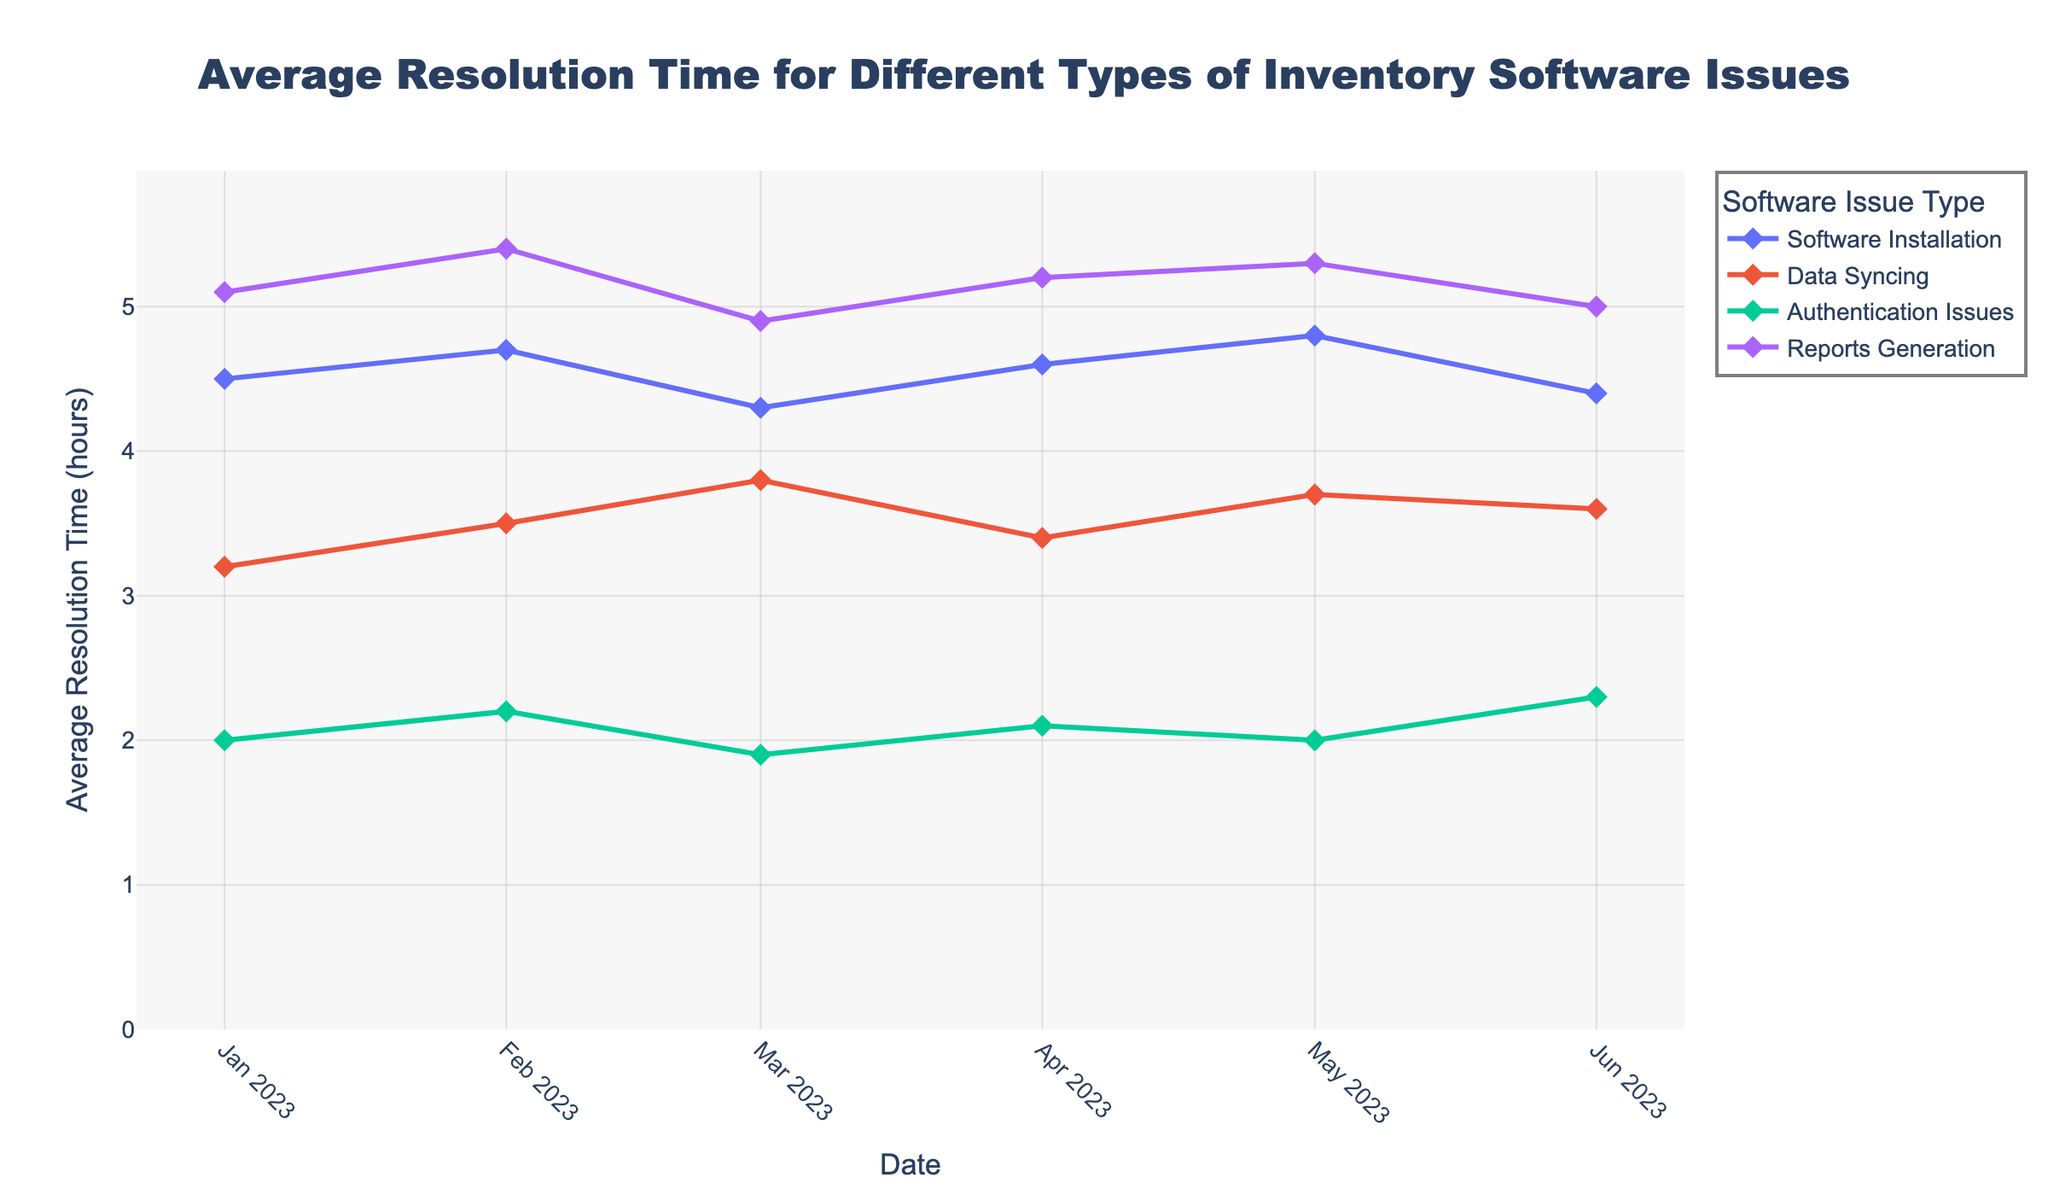What is the title of the plot? The title of the plot is displayed at the top center of the figure. It generally summarizes the main point of the plot.
Answer: Average Resolution Time for Different Types of Inventory Software Issues What is the average resolution time for 'Reports Generation' issues in January 2023? Locate the data point for 'Reports Generation' on January 2023 on the time series plot. The y-axis value at this point indicates the average resolution time.
Answer: 5.1 hours How does the average resolution time for 'Data Syncing' issues in February 2023 compare to that in March 2023? Compare the y-axis values for 'Data Syncing' on the dates February 2023 and March 2023. Subtract the March value from the February value.
Answer: February: 3.5 hours, March: 3.8 hours. Increase by 0.3 hours Which issue type had the lowest average resolution time in June 2023? Find the data points for each issue type in June 2023 and compare their y-axis values. The lowest value indicates the issue type with the shortest resolution time.
Answer: Authentication Issues What is the date range covered in this plot? The x-axis shows the dates of the data points. Determine the first and last dates displayed on the x-axis.
Answer: January 2023 to June 2023 Which software issue type shows the most fluctuation in average resolution time over the given period? For each software issue type, observe the variation in the height of data points across the time series. The one with the widest range indicates the most fluctuation.
Answer: Reports Generation What is the overall trend in resolution times for 'Software Installation' issues from January to June 2023? Observe the sequence of data points for 'Software Installation' from January to June 2023. Determine if the points show an increasing, decreasing, or constant trend.
Answer: Slight fluctuation but generally constant Between May 2023 and June 2023, which issue type saw the biggest increase in average resolution time? Calculate the difference in average resolution time for each issue type between May and June 2023. Identify the issue type with the largest positive difference.
Answer: Authentication Issues (increase by 0.3 hours) What is the average resolution time across all issue types for March 2023? Sum the average resolution times for all issue types in March 2023 and divide by the number of issue types.
Answer: (4.3 + 3.8 + 1.9 + 4.9) / 4 = 14.9 / 4 = 3.725 hours How many unique issue types are plotted in the figure? Identify the different lines in the plot, each representing a unique issue type. Count the total number.
Answer: 4 